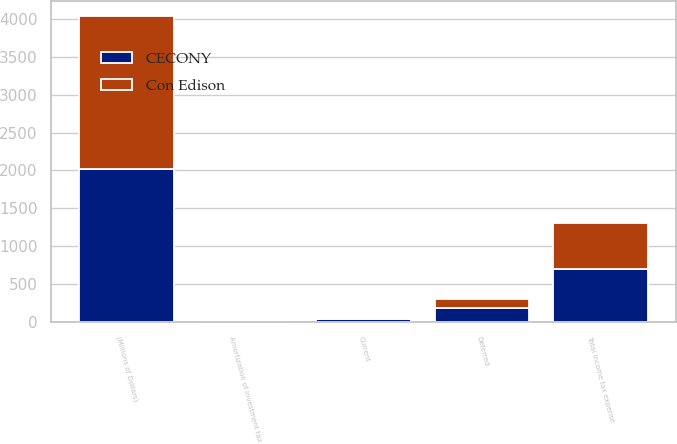<chart> <loc_0><loc_0><loc_500><loc_500><stacked_bar_chart><ecel><fcel>(Millions of Dollars)<fcel>Current<fcel>Deferred<fcel>Amortization of investment tax<fcel>Total income tax expense<nl><fcel>CECONY<fcel>2016<fcel>42<fcel>188<fcel>9<fcel>698<nl><fcel>Con Edison<fcel>2016<fcel>1<fcel>114<fcel>4<fcel>603<nl></chart> 